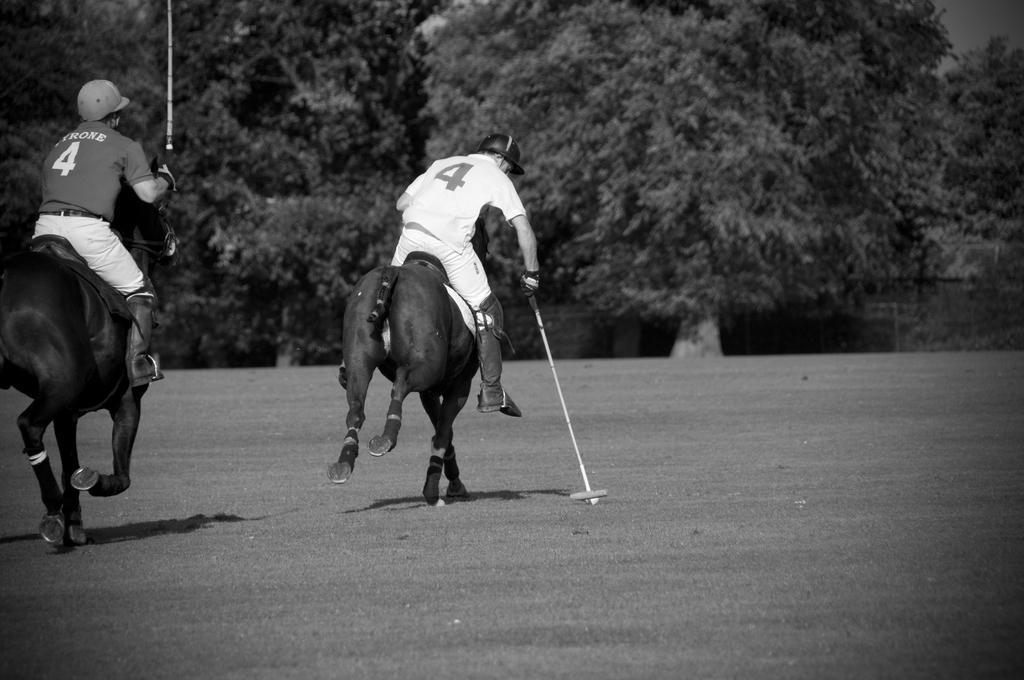Please provide a concise description of this image. In this picture we can see a ground where two men sitting on animals and riding. They both wore caps. These are trees and it is a black & white picture. 